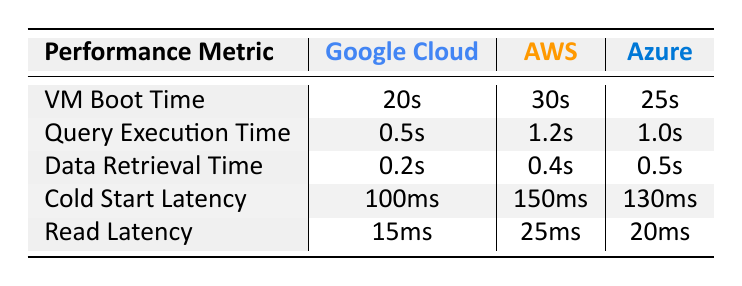What is the VM Boot Time for Google Cloud Platform? The table lists the VM Boot Time for Google Cloud Platform as 20 seconds.
Answer: 20 seconds Which cloud provider has the shortest Query Execution Time? Google Cloud Platform has the shortest Query Execution Time at 0.5 seconds compared to AWS's 1.2 seconds and Azure's 1.0 seconds.
Answer: Google Cloud Platform What is the difference in Data Retrieval Time between AWS and Google Cloud? AWS has a Data Retrieval Time of 0.4 seconds and Google Cloud has 0.2 seconds. The difference is 0.4 - 0.2 = 0.2 seconds.
Answer: 0.2 seconds Is the Cold Start Latency for Microsoft Azure better than Google Cloud? Microsoft Azure's Cold Start Latency is 130 milliseconds, which is worse (higher) than Google Cloud's 100 milliseconds. Therefore, it is not better.
Answer: No What is the average Read Latency for the three providers? To find the average, add the Read Latency values: (15 + 25 + 20) = 60 milliseconds. Then, divide by the number of providers, which is 3: 60/3 = 20 milliseconds.
Answer: 20 milliseconds Which provider has the longest Cold Start Latency? AWS has the longest Cold Start Latency at 150 milliseconds, compared to Google Cloud's 100 milliseconds and Azure's 130 milliseconds.
Answer: Amazon Web Services Calculate the total time for VM Boot Time and Query Execution Time for Google Cloud. For Google Cloud, the VM Boot Time is 20 seconds and the Query Execution Time is 0.5 seconds. Adding them gives 20 + 0.5 = 20.5 seconds.
Answer: 20.5 seconds Does Google Cloud have the best performance across all metrics listed in the table? Based on the table, Google Cloud has the best performance in all listed metrics: lowest VM Boot Time, Query Execution Time, Data Retrieval Time, Cold Start Latency, and Read Latency.
Answer: Yes What is the ratio of Google Cloud's Data Retrieval Time to AWS's Data Retrieval Time? Google Cloud's Data Retrieval Time is 0.2 seconds and AWS's is 0.4 seconds. The ratio is 0.2 / 0.4 = 0.5.
Answer: 0.5 Which service has a higher Read Latency, AWS or Azure? AWS has a Read Latency of 25 milliseconds, while Azure has 20 milliseconds. Therefore, AWS has the higher Read Latency.
Answer: AWS 